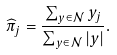<formula> <loc_0><loc_0><loc_500><loc_500>\widehat { \pi } _ { j } = \frac { \sum _ { y \in \mathcal { N } } { y _ { j } } } { \sum _ { y \in \mathcal { N } } | y | } .</formula> 